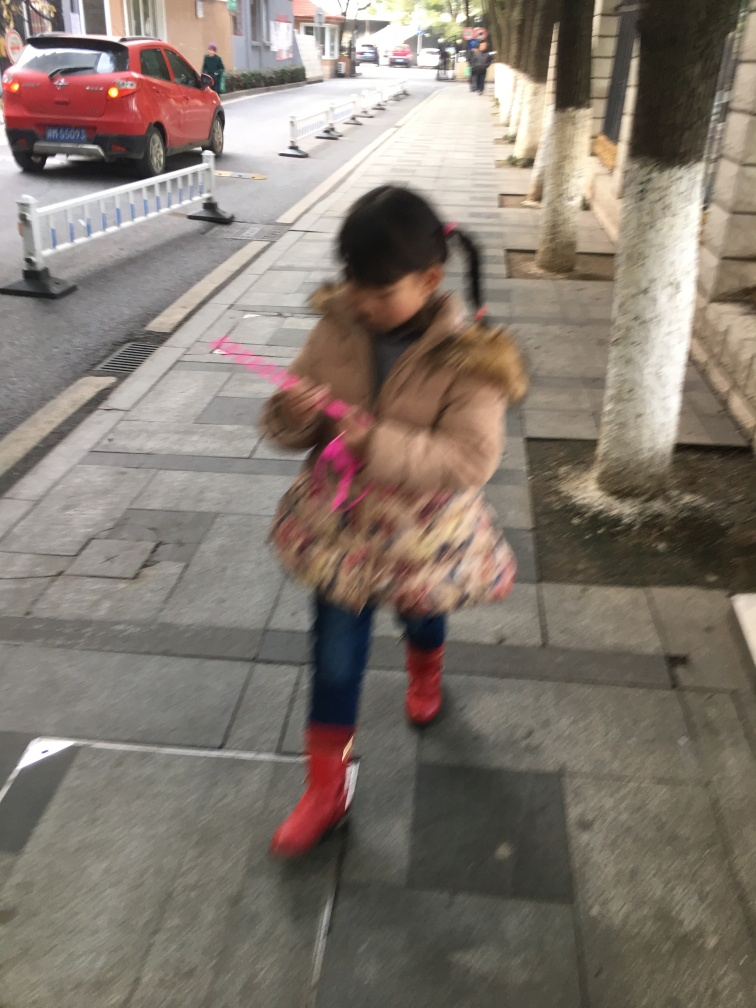Does the image have low sharpness?
A. No
B. Yes
Answer with the option's letter from the given choices directly.
 B. 